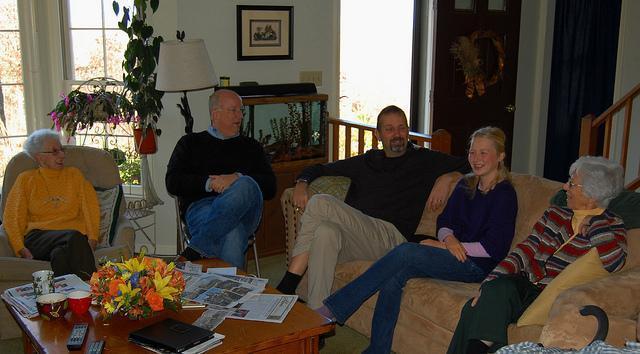How many people are in the photo?
Give a very brief answer. 5. How many fingers does grandma on the far left have showing?
Give a very brief answer. 0. How many people are there?
Give a very brief answer. 5. How many people are in the room?
Give a very brief answer. 5. How many people are standing?
Give a very brief answer. 0. How many people are taking pictures?
Give a very brief answer. 1. How many couches can you see?
Give a very brief answer. 1. How many potted plants can you see?
Give a very brief answer. 3. How many people can be seen?
Give a very brief answer. 5. 